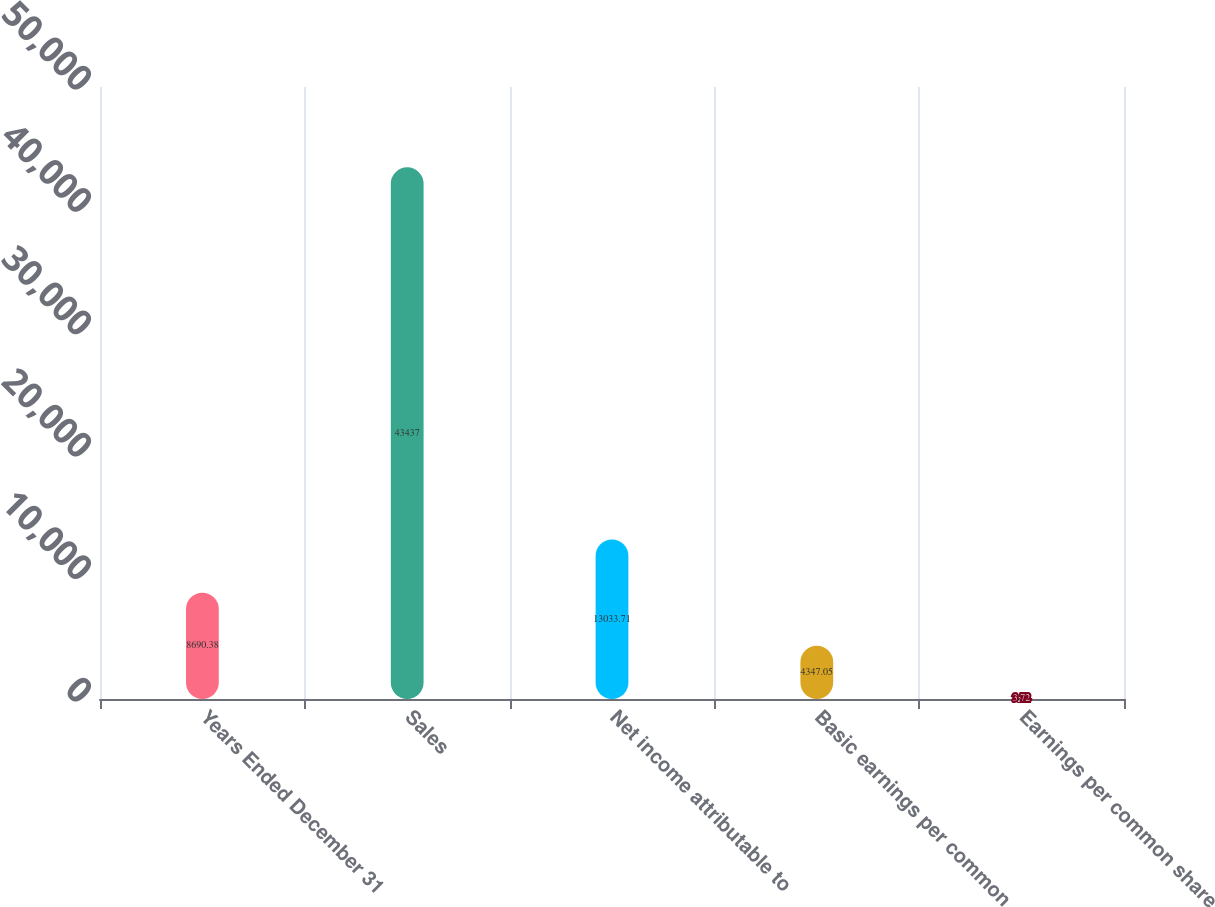<chart> <loc_0><loc_0><loc_500><loc_500><bar_chart><fcel>Years Ended December 31<fcel>Sales<fcel>Net income attributable to<fcel>Basic earnings per common<fcel>Earnings per common share<nl><fcel>8690.38<fcel>43437<fcel>13033.7<fcel>4347.05<fcel>3.72<nl></chart> 